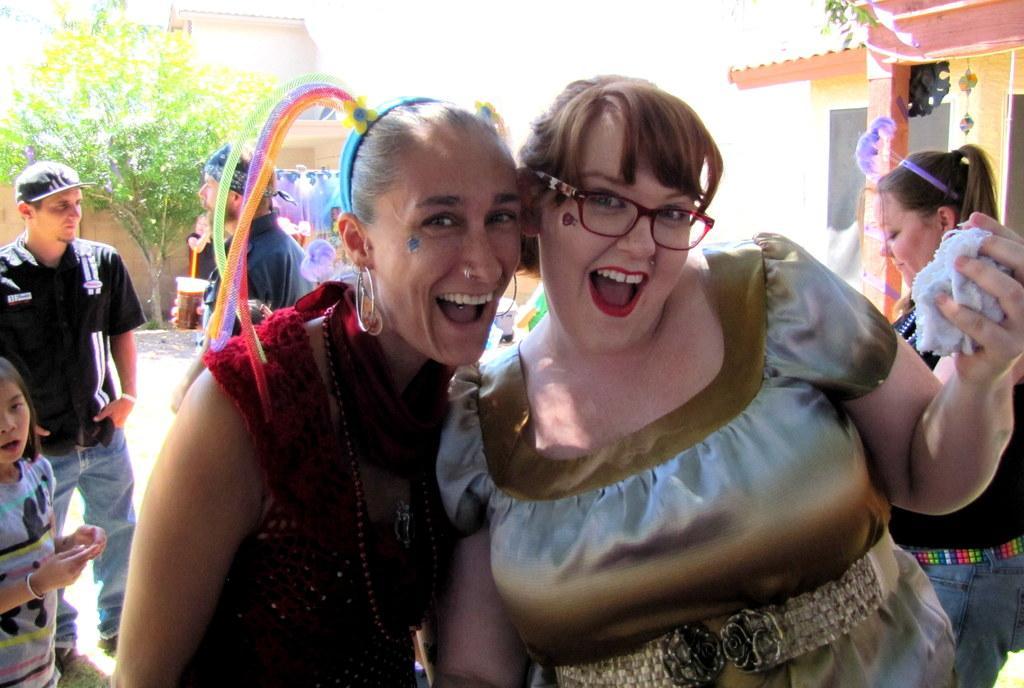Can you describe this image briefly? In the image we can see two women wearing clothes and they are smiling. The right side woman is wearing spectacles and holding a cloth in her hand, and the left side woman is wearing earrings and a nose ring. Behind them there are other people standing and wearing clothes. Here we can see the tree and the building. 